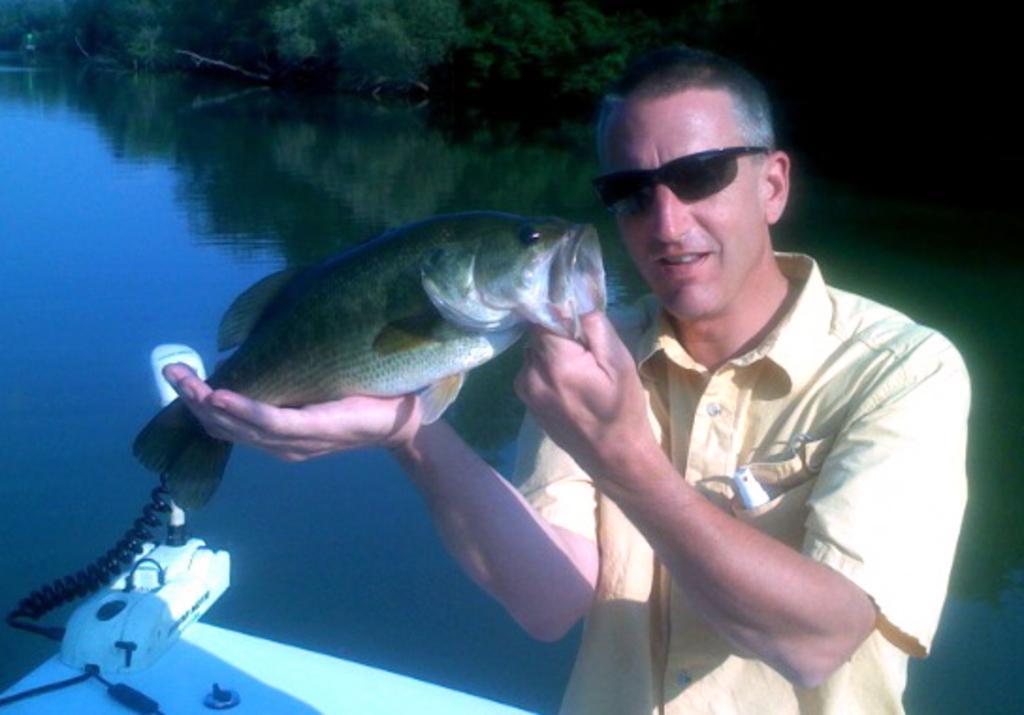Describe this image in one or two sentences. In this image we can see one man standing in the boat and holding a fish. There is one boat on the river, few objects on the boat, some trees in the background and the background is dark. 